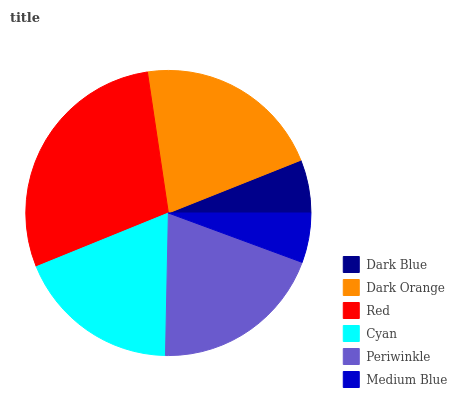Is Medium Blue the minimum?
Answer yes or no. Yes. Is Red the maximum?
Answer yes or no. Yes. Is Dark Orange the minimum?
Answer yes or no. No. Is Dark Orange the maximum?
Answer yes or no. No. Is Dark Orange greater than Dark Blue?
Answer yes or no. Yes. Is Dark Blue less than Dark Orange?
Answer yes or no. Yes. Is Dark Blue greater than Dark Orange?
Answer yes or no. No. Is Dark Orange less than Dark Blue?
Answer yes or no. No. Is Periwinkle the high median?
Answer yes or no. Yes. Is Cyan the low median?
Answer yes or no. Yes. Is Dark Orange the high median?
Answer yes or no. No. Is Periwinkle the low median?
Answer yes or no. No. 